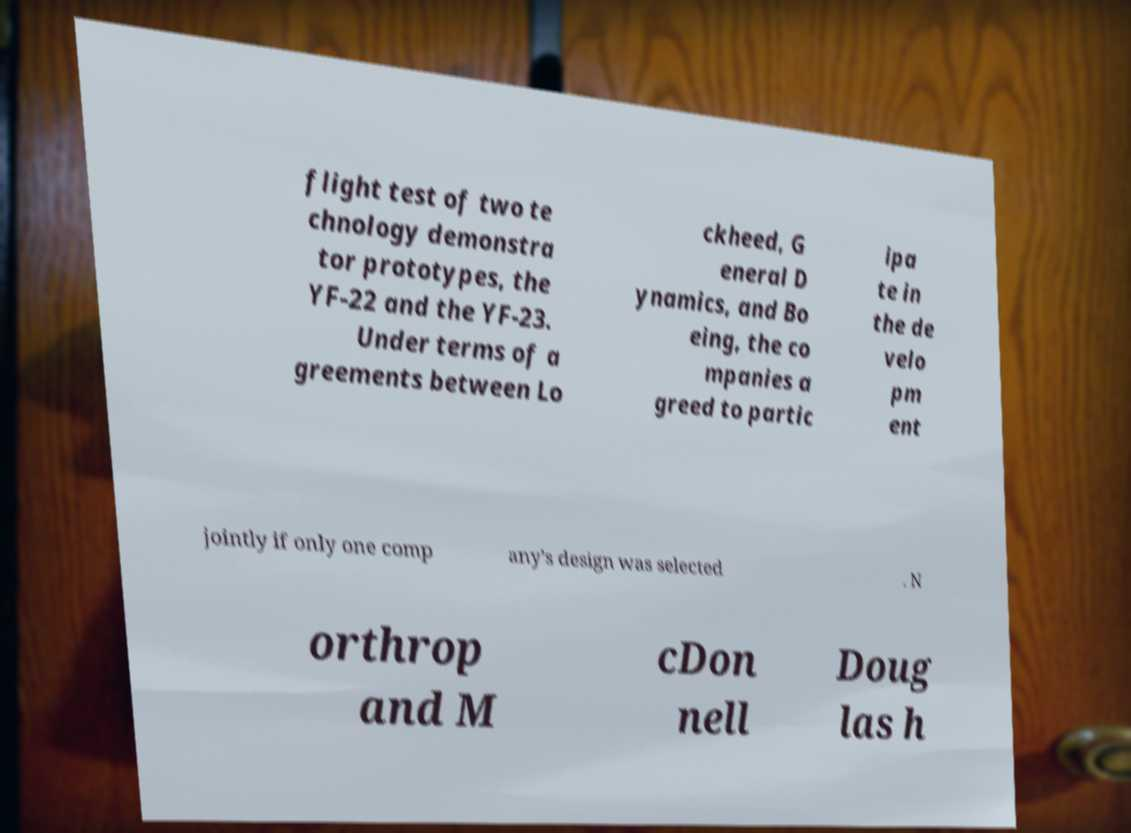I need the written content from this picture converted into text. Can you do that? flight test of two te chnology demonstra tor prototypes, the YF-22 and the YF-23. Under terms of a greements between Lo ckheed, G eneral D ynamics, and Bo eing, the co mpanies a greed to partic ipa te in the de velo pm ent jointly if only one comp any's design was selected . N orthrop and M cDon nell Doug las h 